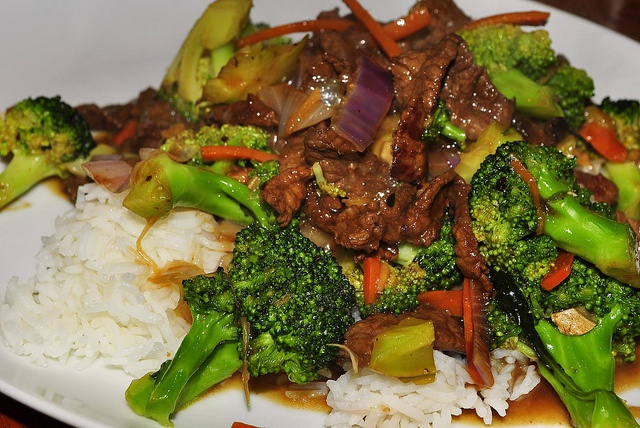Describe the objects in this image and their specific colors. I can see broccoli in darkgray, black, darkgreen, and olive tones, broccoli in darkgray, black, darkgreen, and olive tones, broccoli in darkgray, olive, and black tones, broccoli in darkgray, olive, and black tones, and broccoli in darkgray, olive, and maroon tones in this image. 